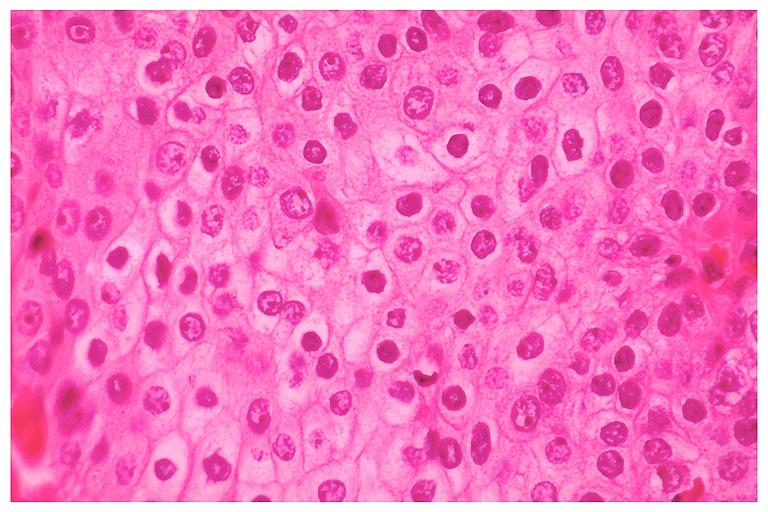s oral present?
Answer the question using a single word or phrase. Yes 